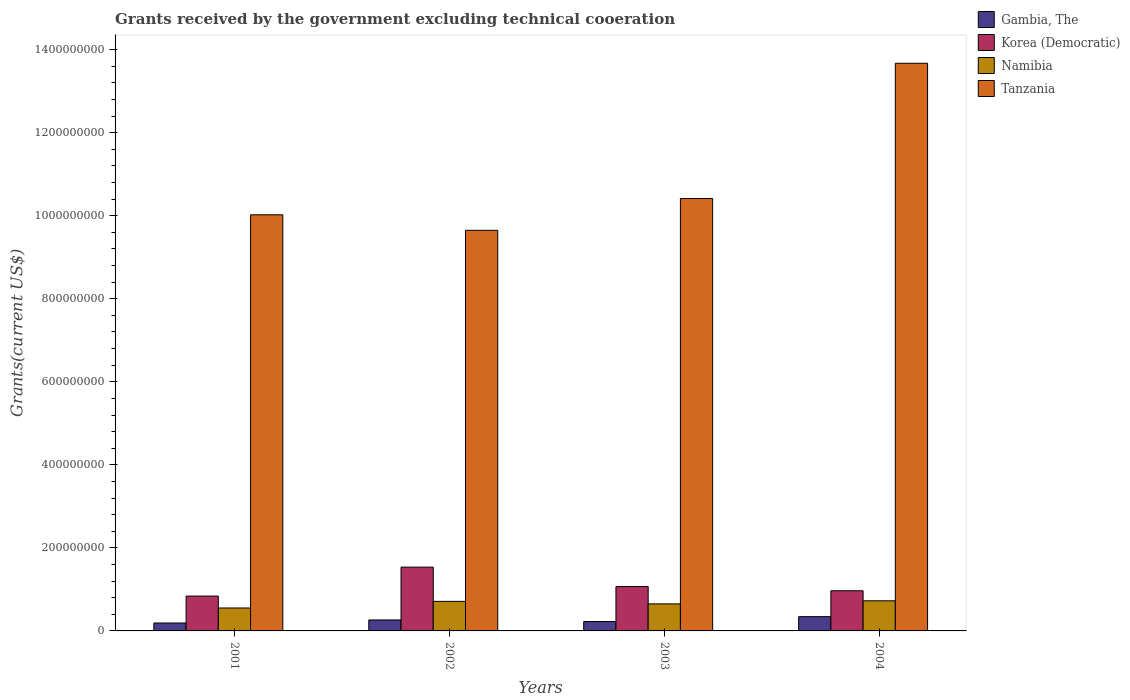Are the number of bars per tick equal to the number of legend labels?
Keep it short and to the point. Yes. How many bars are there on the 2nd tick from the left?
Offer a terse response. 4. How many bars are there on the 4th tick from the right?
Your response must be concise. 4. What is the total grants received by the government in Gambia, The in 2003?
Your answer should be compact. 2.27e+07. Across all years, what is the maximum total grants received by the government in Tanzania?
Offer a very short reply. 1.37e+09. Across all years, what is the minimum total grants received by the government in Gambia, The?
Keep it short and to the point. 1.91e+07. In which year was the total grants received by the government in Korea (Democratic) maximum?
Offer a terse response. 2002. In which year was the total grants received by the government in Namibia minimum?
Offer a very short reply. 2001. What is the total total grants received by the government in Gambia, The in the graph?
Your answer should be compact. 1.03e+08. What is the difference between the total grants received by the government in Gambia, The in 2001 and that in 2004?
Your answer should be compact. -1.53e+07. What is the difference between the total grants received by the government in Tanzania in 2003 and the total grants received by the government in Gambia, The in 2004?
Keep it short and to the point. 1.01e+09. What is the average total grants received by the government in Tanzania per year?
Provide a succinct answer. 1.09e+09. In the year 2001, what is the difference between the total grants received by the government in Tanzania and total grants received by the government in Korea (Democratic)?
Provide a short and direct response. 9.18e+08. What is the ratio of the total grants received by the government in Korea (Democratic) in 2001 to that in 2002?
Offer a very short reply. 0.55. Is the total grants received by the government in Gambia, The in 2002 less than that in 2004?
Provide a short and direct response. Yes. Is the difference between the total grants received by the government in Tanzania in 2002 and 2004 greater than the difference between the total grants received by the government in Korea (Democratic) in 2002 and 2004?
Make the answer very short. No. What is the difference between the highest and the second highest total grants received by the government in Tanzania?
Offer a terse response. 3.26e+08. What is the difference between the highest and the lowest total grants received by the government in Korea (Democratic)?
Your answer should be compact. 6.97e+07. Is the sum of the total grants received by the government in Gambia, The in 2001 and 2004 greater than the maximum total grants received by the government in Namibia across all years?
Offer a terse response. No. What does the 3rd bar from the left in 2001 represents?
Your answer should be very brief. Namibia. What does the 2nd bar from the right in 2003 represents?
Provide a succinct answer. Namibia. Are all the bars in the graph horizontal?
Offer a terse response. No. What is the difference between two consecutive major ticks on the Y-axis?
Your answer should be compact. 2.00e+08. Does the graph contain grids?
Make the answer very short. No. Where does the legend appear in the graph?
Your response must be concise. Top right. What is the title of the graph?
Offer a very short reply. Grants received by the government excluding technical cooeration. What is the label or title of the X-axis?
Provide a succinct answer. Years. What is the label or title of the Y-axis?
Ensure brevity in your answer.  Grants(current US$). What is the Grants(current US$) in Gambia, The in 2001?
Provide a succinct answer. 1.91e+07. What is the Grants(current US$) of Korea (Democratic) in 2001?
Offer a very short reply. 8.39e+07. What is the Grants(current US$) in Namibia in 2001?
Ensure brevity in your answer.  5.52e+07. What is the Grants(current US$) of Tanzania in 2001?
Your answer should be compact. 1.00e+09. What is the Grants(current US$) of Gambia, The in 2002?
Your answer should be very brief. 2.64e+07. What is the Grants(current US$) of Korea (Democratic) in 2002?
Offer a very short reply. 1.54e+08. What is the Grants(current US$) of Namibia in 2002?
Offer a terse response. 7.12e+07. What is the Grants(current US$) of Tanzania in 2002?
Your response must be concise. 9.65e+08. What is the Grants(current US$) of Gambia, The in 2003?
Your response must be concise. 2.27e+07. What is the Grants(current US$) in Korea (Democratic) in 2003?
Ensure brevity in your answer.  1.07e+08. What is the Grants(current US$) in Namibia in 2003?
Give a very brief answer. 6.51e+07. What is the Grants(current US$) in Tanzania in 2003?
Provide a succinct answer. 1.04e+09. What is the Grants(current US$) in Gambia, The in 2004?
Provide a succinct answer. 3.44e+07. What is the Grants(current US$) of Korea (Democratic) in 2004?
Your answer should be compact. 9.68e+07. What is the Grants(current US$) in Namibia in 2004?
Your answer should be compact. 7.25e+07. What is the Grants(current US$) of Tanzania in 2004?
Provide a succinct answer. 1.37e+09. Across all years, what is the maximum Grants(current US$) of Gambia, The?
Your answer should be very brief. 3.44e+07. Across all years, what is the maximum Grants(current US$) in Korea (Democratic)?
Ensure brevity in your answer.  1.54e+08. Across all years, what is the maximum Grants(current US$) of Namibia?
Your answer should be compact. 7.25e+07. Across all years, what is the maximum Grants(current US$) of Tanzania?
Keep it short and to the point. 1.37e+09. Across all years, what is the minimum Grants(current US$) in Gambia, The?
Offer a very short reply. 1.91e+07. Across all years, what is the minimum Grants(current US$) of Korea (Democratic)?
Offer a terse response. 8.39e+07. Across all years, what is the minimum Grants(current US$) in Namibia?
Give a very brief answer. 5.52e+07. Across all years, what is the minimum Grants(current US$) in Tanzania?
Ensure brevity in your answer.  9.65e+08. What is the total Grants(current US$) in Gambia, The in the graph?
Your answer should be compact. 1.03e+08. What is the total Grants(current US$) of Korea (Democratic) in the graph?
Offer a very short reply. 4.41e+08. What is the total Grants(current US$) in Namibia in the graph?
Your response must be concise. 2.64e+08. What is the total Grants(current US$) of Tanzania in the graph?
Give a very brief answer. 4.38e+09. What is the difference between the Grants(current US$) in Gambia, The in 2001 and that in 2002?
Your answer should be very brief. -7.32e+06. What is the difference between the Grants(current US$) in Korea (Democratic) in 2001 and that in 2002?
Keep it short and to the point. -6.97e+07. What is the difference between the Grants(current US$) in Namibia in 2001 and that in 2002?
Offer a terse response. -1.60e+07. What is the difference between the Grants(current US$) of Tanzania in 2001 and that in 2002?
Give a very brief answer. 3.74e+07. What is the difference between the Grants(current US$) in Gambia, The in 2001 and that in 2003?
Your answer should be compact. -3.60e+06. What is the difference between the Grants(current US$) in Korea (Democratic) in 2001 and that in 2003?
Provide a succinct answer. -2.30e+07. What is the difference between the Grants(current US$) of Namibia in 2001 and that in 2003?
Offer a terse response. -9.90e+06. What is the difference between the Grants(current US$) in Tanzania in 2001 and that in 2003?
Offer a very short reply. -3.92e+07. What is the difference between the Grants(current US$) in Gambia, The in 2001 and that in 2004?
Your response must be concise. -1.53e+07. What is the difference between the Grants(current US$) in Korea (Democratic) in 2001 and that in 2004?
Give a very brief answer. -1.29e+07. What is the difference between the Grants(current US$) of Namibia in 2001 and that in 2004?
Provide a succinct answer. -1.73e+07. What is the difference between the Grants(current US$) of Tanzania in 2001 and that in 2004?
Ensure brevity in your answer.  -3.65e+08. What is the difference between the Grants(current US$) of Gambia, The in 2002 and that in 2003?
Your answer should be compact. 3.72e+06. What is the difference between the Grants(current US$) of Korea (Democratic) in 2002 and that in 2003?
Offer a terse response. 4.67e+07. What is the difference between the Grants(current US$) of Namibia in 2002 and that in 2003?
Ensure brevity in your answer.  6.06e+06. What is the difference between the Grants(current US$) of Tanzania in 2002 and that in 2003?
Keep it short and to the point. -7.66e+07. What is the difference between the Grants(current US$) of Gambia, The in 2002 and that in 2004?
Your answer should be compact. -7.96e+06. What is the difference between the Grants(current US$) in Korea (Democratic) in 2002 and that in 2004?
Keep it short and to the point. 5.69e+07. What is the difference between the Grants(current US$) of Namibia in 2002 and that in 2004?
Provide a short and direct response. -1.34e+06. What is the difference between the Grants(current US$) of Tanzania in 2002 and that in 2004?
Your answer should be very brief. -4.02e+08. What is the difference between the Grants(current US$) in Gambia, The in 2003 and that in 2004?
Offer a very short reply. -1.17e+07. What is the difference between the Grants(current US$) in Korea (Democratic) in 2003 and that in 2004?
Keep it short and to the point. 1.01e+07. What is the difference between the Grants(current US$) of Namibia in 2003 and that in 2004?
Provide a short and direct response. -7.40e+06. What is the difference between the Grants(current US$) in Tanzania in 2003 and that in 2004?
Your answer should be very brief. -3.26e+08. What is the difference between the Grants(current US$) of Gambia, The in 2001 and the Grants(current US$) of Korea (Democratic) in 2002?
Your response must be concise. -1.35e+08. What is the difference between the Grants(current US$) in Gambia, The in 2001 and the Grants(current US$) in Namibia in 2002?
Provide a short and direct response. -5.21e+07. What is the difference between the Grants(current US$) in Gambia, The in 2001 and the Grants(current US$) in Tanzania in 2002?
Keep it short and to the point. -9.46e+08. What is the difference between the Grants(current US$) of Korea (Democratic) in 2001 and the Grants(current US$) of Namibia in 2002?
Offer a very short reply. 1.27e+07. What is the difference between the Grants(current US$) of Korea (Democratic) in 2001 and the Grants(current US$) of Tanzania in 2002?
Your response must be concise. -8.81e+08. What is the difference between the Grants(current US$) in Namibia in 2001 and the Grants(current US$) in Tanzania in 2002?
Give a very brief answer. -9.10e+08. What is the difference between the Grants(current US$) in Gambia, The in 2001 and the Grants(current US$) in Korea (Democratic) in 2003?
Give a very brief answer. -8.78e+07. What is the difference between the Grants(current US$) in Gambia, The in 2001 and the Grants(current US$) in Namibia in 2003?
Make the answer very short. -4.61e+07. What is the difference between the Grants(current US$) in Gambia, The in 2001 and the Grants(current US$) in Tanzania in 2003?
Make the answer very short. -1.02e+09. What is the difference between the Grants(current US$) in Korea (Democratic) in 2001 and the Grants(current US$) in Namibia in 2003?
Keep it short and to the point. 1.88e+07. What is the difference between the Grants(current US$) in Korea (Democratic) in 2001 and the Grants(current US$) in Tanzania in 2003?
Your answer should be very brief. -9.58e+08. What is the difference between the Grants(current US$) in Namibia in 2001 and the Grants(current US$) in Tanzania in 2003?
Provide a succinct answer. -9.86e+08. What is the difference between the Grants(current US$) in Gambia, The in 2001 and the Grants(current US$) in Korea (Democratic) in 2004?
Keep it short and to the point. -7.77e+07. What is the difference between the Grants(current US$) in Gambia, The in 2001 and the Grants(current US$) in Namibia in 2004?
Offer a terse response. -5.35e+07. What is the difference between the Grants(current US$) in Gambia, The in 2001 and the Grants(current US$) in Tanzania in 2004?
Your answer should be compact. -1.35e+09. What is the difference between the Grants(current US$) of Korea (Democratic) in 2001 and the Grants(current US$) of Namibia in 2004?
Keep it short and to the point. 1.14e+07. What is the difference between the Grants(current US$) of Korea (Democratic) in 2001 and the Grants(current US$) of Tanzania in 2004?
Give a very brief answer. -1.28e+09. What is the difference between the Grants(current US$) of Namibia in 2001 and the Grants(current US$) of Tanzania in 2004?
Ensure brevity in your answer.  -1.31e+09. What is the difference between the Grants(current US$) in Gambia, The in 2002 and the Grants(current US$) in Korea (Democratic) in 2003?
Ensure brevity in your answer.  -8.05e+07. What is the difference between the Grants(current US$) of Gambia, The in 2002 and the Grants(current US$) of Namibia in 2003?
Provide a short and direct response. -3.87e+07. What is the difference between the Grants(current US$) in Gambia, The in 2002 and the Grants(current US$) in Tanzania in 2003?
Provide a succinct answer. -1.02e+09. What is the difference between the Grants(current US$) in Korea (Democratic) in 2002 and the Grants(current US$) in Namibia in 2003?
Provide a succinct answer. 8.85e+07. What is the difference between the Grants(current US$) in Korea (Democratic) in 2002 and the Grants(current US$) in Tanzania in 2003?
Give a very brief answer. -8.88e+08. What is the difference between the Grants(current US$) of Namibia in 2002 and the Grants(current US$) of Tanzania in 2003?
Provide a short and direct response. -9.70e+08. What is the difference between the Grants(current US$) in Gambia, The in 2002 and the Grants(current US$) in Korea (Democratic) in 2004?
Give a very brief answer. -7.04e+07. What is the difference between the Grants(current US$) of Gambia, The in 2002 and the Grants(current US$) of Namibia in 2004?
Provide a succinct answer. -4.61e+07. What is the difference between the Grants(current US$) of Gambia, The in 2002 and the Grants(current US$) of Tanzania in 2004?
Offer a very short reply. -1.34e+09. What is the difference between the Grants(current US$) in Korea (Democratic) in 2002 and the Grants(current US$) in Namibia in 2004?
Provide a short and direct response. 8.11e+07. What is the difference between the Grants(current US$) in Korea (Democratic) in 2002 and the Grants(current US$) in Tanzania in 2004?
Your response must be concise. -1.21e+09. What is the difference between the Grants(current US$) of Namibia in 2002 and the Grants(current US$) of Tanzania in 2004?
Your answer should be very brief. -1.30e+09. What is the difference between the Grants(current US$) of Gambia, The in 2003 and the Grants(current US$) of Korea (Democratic) in 2004?
Give a very brief answer. -7.41e+07. What is the difference between the Grants(current US$) of Gambia, The in 2003 and the Grants(current US$) of Namibia in 2004?
Give a very brief answer. -4.99e+07. What is the difference between the Grants(current US$) in Gambia, The in 2003 and the Grants(current US$) in Tanzania in 2004?
Provide a short and direct response. -1.34e+09. What is the difference between the Grants(current US$) of Korea (Democratic) in 2003 and the Grants(current US$) of Namibia in 2004?
Give a very brief answer. 3.44e+07. What is the difference between the Grants(current US$) in Korea (Democratic) in 2003 and the Grants(current US$) in Tanzania in 2004?
Provide a short and direct response. -1.26e+09. What is the difference between the Grants(current US$) of Namibia in 2003 and the Grants(current US$) of Tanzania in 2004?
Provide a short and direct response. -1.30e+09. What is the average Grants(current US$) of Gambia, The per year?
Offer a very short reply. 2.56e+07. What is the average Grants(current US$) in Korea (Democratic) per year?
Provide a short and direct response. 1.10e+08. What is the average Grants(current US$) of Namibia per year?
Provide a short and direct response. 6.60e+07. What is the average Grants(current US$) in Tanzania per year?
Provide a short and direct response. 1.09e+09. In the year 2001, what is the difference between the Grants(current US$) in Gambia, The and Grants(current US$) in Korea (Democratic)?
Your answer should be compact. -6.48e+07. In the year 2001, what is the difference between the Grants(current US$) of Gambia, The and Grants(current US$) of Namibia?
Provide a short and direct response. -3.62e+07. In the year 2001, what is the difference between the Grants(current US$) of Gambia, The and Grants(current US$) of Tanzania?
Your answer should be compact. -9.83e+08. In the year 2001, what is the difference between the Grants(current US$) in Korea (Democratic) and Grants(current US$) in Namibia?
Provide a short and direct response. 2.87e+07. In the year 2001, what is the difference between the Grants(current US$) in Korea (Democratic) and Grants(current US$) in Tanzania?
Give a very brief answer. -9.18e+08. In the year 2001, what is the difference between the Grants(current US$) in Namibia and Grants(current US$) in Tanzania?
Keep it short and to the point. -9.47e+08. In the year 2002, what is the difference between the Grants(current US$) of Gambia, The and Grants(current US$) of Korea (Democratic)?
Offer a very short reply. -1.27e+08. In the year 2002, what is the difference between the Grants(current US$) in Gambia, The and Grants(current US$) in Namibia?
Your answer should be very brief. -4.48e+07. In the year 2002, what is the difference between the Grants(current US$) of Gambia, The and Grants(current US$) of Tanzania?
Your answer should be compact. -9.38e+08. In the year 2002, what is the difference between the Grants(current US$) of Korea (Democratic) and Grants(current US$) of Namibia?
Your answer should be compact. 8.25e+07. In the year 2002, what is the difference between the Grants(current US$) in Korea (Democratic) and Grants(current US$) in Tanzania?
Your response must be concise. -8.11e+08. In the year 2002, what is the difference between the Grants(current US$) of Namibia and Grants(current US$) of Tanzania?
Give a very brief answer. -8.94e+08. In the year 2003, what is the difference between the Grants(current US$) in Gambia, The and Grants(current US$) in Korea (Democratic)?
Give a very brief answer. -8.42e+07. In the year 2003, what is the difference between the Grants(current US$) of Gambia, The and Grants(current US$) of Namibia?
Keep it short and to the point. -4.25e+07. In the year 2003, what is the difference between the Grants(current US$) of Gambia, The and Grants(current US$) of Tanzania?
Offer a very short reply. -1.02e+09. In the year 2003, what is the difference between the Grants(current US$) in Korea (Democratic) and Grants(current US$) in Namibia?
Offer a very short reply. 4.18e+07. In the year 2003, what is the difference between the Grants(current US$) of Korea (Democratic) and Grants(current US$) of Tanzania?
Offer a terse response. -9.35e+08. In the year 2003, what is the difference between the Grants(current US$) of Namibia and Grants(current US$) of Tanzania?
Ensure brevity in your answer.  -9.76e+08. In the year 2004, what is the difference between the Grants(current US$) in Gambia, The and Grants(current US$) in Korea (Democratic)?
Make the answer very short. -6.24e+07. In the year 2004, what is the difference between the Grants(current US$) in Gambia, The and Grants(current US$) in Namibia?
Keep it short and to the point. -3.82e+07. In the year 2004, what is the difference between the Grants(current US$) in Gambia, The and Grants(current US$) in Tanzania?
Provide a succinct answer. -1.33e+09. In the year 2004, what is the difference between the Grants(current US$) in Korea (Democratic) and Grants(current US$) in Namibia?
Offer a very short reply. 2.42e+07. In the year 2004, what is the difference between the Grants(current US$) in Korea (Democratic) and Grants(current US$) in Tanzania?
Your answer should be compact. -1.27e+09. In the year 2004, what is the difference between the Grants(current US$) of Namibia and Grants(current US$) of Tanzania?
Give a very brief answer. -1.29e+09. What is the ratio of the Grants(current US$) in Gambia, The in 2001 to that in 2002?
Your response must be concise. 0.72. What is the ratio of the Grants(current US$) in Korea (Democratic) in 2001 to that in 2002?
Your answer should be very brief. 0.55. What is the ratio of the Grants(current US$) of Namibia in 2001 to that in 2002?
Provide a short and direct response. 0.78. What is the ratio of the Grants(current US$) of Tanzania in 2001 to that in 2002?
Ensure brevity in your answer.  1.04. What is the ratio of the Grants(current US$) of Gambia, The in 2001 to that in 2003?
Your answer should be compact. 0.84. What is the ratio of the Grants(current US$) in Korea (Democratic) in 2001 to that in 2003?
Offer a terse response. 0.78. What is the ratio of the Grants(current US$) in Namibia in 2001 to that in 2003?
Ensure brevity in your answer.  0.85. What is the ratio of the Grants(current US$) in Tanzania in 2001 to that in 2003?
Provide a succinct answer. 0.96. What is the ratio of the Grants(current US$) in Gambia, The in 2001 to that in 2004?
Your answer should be compact. 0.56. What is the ratio of the Grants(current US$) in Korea (Democratic) in 2001 to that in 2004?
Your answer should be very brief. 0.87. What is the ratio of the Grants(current US$) of Namibia in 2001 to that in 2004?
Your response must be concise. 0.76. What is the ratio of the Grants(current US$) in Tanzania in 2001 to that in 2004?
Ensure brevity in your answer.  0.73. What is the ratio of the Grants(current US$) in Gambia, The in 2002 to that in 2003?
Offer a terse response. 1.16. What is the ratio of the Grants(current US$) of Korea (Democratic) in 2002 to that in 2003?
Offer a terse response. 1.44. What is the ratio of the Grants(current US$) of Namibia in 2002 to that in 2003?
Make the answer very short. 1.09. What is the ratio of the Grants(current US$) in Tanzania in 2002 to that in 2003?
Provide a succinct answer. 0.93. What is the ratio of the Grants(current US$) in Gambia, The in 2002 to that in 2004?
Give a very brief answer. 0.77. What is the ratio of the Grants(current US$) in Korea (Democratic) in 2002 to that in 2004?
Your response must be concise. 1.59. What is the ratio of the Grants(current US$) of Namibia in 2002 to that in 2004?
Provide a succinct answer. 0.98. What is the ratio of the Grants(current US$) in Tanzania in 2002 to that in 2004?
Offer a very short reply. 0.71. What is the ratio of the Grants(current US$) of Gambia, The in 2003 to that in 2004?
Make the answer very short. 0.66. What is the ratio of the Grants(current US$) of Korea (Democratic) in 2003 to that in 2004?
Keep it short and to the point. 1.1. What is the ratio of the Grants(current US$) of Namibia in 2003 to that in 2004?
Offer a terse response. 0.9. What is the ratio of the Grants(current US$) of Tanzania in 2003 to that in 2004?
Provide a succinct answer. 0.76. What is the difference between the highest and the second highest Grants(current US$) of Gambia, The?
Offer a very short reply. 7.96e+06. What is the difference between the highest and the second highest Grants(current US$) in Korea (Democratic)?
Give a very brief answer. 4.67e+07. What is the difference between the highest and the second highest Grants(current US$) of Namibia?
Offer a very short reply. 1.34e+06. What is the difference between the highest and the second highest Grants(current US$) in Tanzania?
Offer a very short reply. 3.26e+08. What is the difference between the highest and the lowest Grants(current US$) in Gambia, The?
Your answer should be very brief. 1.53e+07. What is the difference between the highest and the lowest Grants(current US$) in Korea (Democratic)?
Your answer should be very brief. 6.97e+07. What is the difference between the highest and the lowest Grants(current US$) in Namibia?
Ensure brevity in your answer.  1.73e+07. What is the difference between the highest and the lowest Grants(current US$) of Tanzania?
Provide a succinct answer. 4.02e+08. 